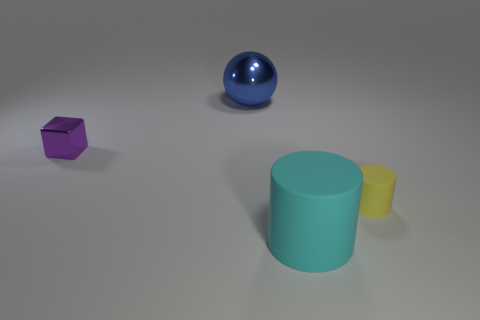There is a cyan matte object that is the same shape as the yellow matte thing; what size is it?
Provide a short and direct response. Large. What number of things are either small objects that are right of the shiny cube or objects right of the purple cube?
Provide a short and direct response. 3. Does the blue object have the same size as the cylinder that is in front of the yellow object?
Keep it short and to the point. Yes. Are the object in front of the small yellow matte cylinder and the small thing that is to the left of the tiny yellow cylinder made of the same material?
Ensure brevity in your answer.  No. Is the number of metal objects left of the big cylinder the same as the number of small matte cylinders behind the metal cube?
Offer a terse response. No. How many metal blocks are the same color as the big cylinder?
Keep it short and to the point. 0. What number of shiny things are either big spheres or red things?
Make the answer very short. 1. Do the small object on the right side of the big cylinder and the big thing that is behind the small purple shiny block have the same shape?
Offer a very short reply. No. There is a blue metallic sphere; how many spheres are behind it?
Provide a short and direct response. 0. Are there any big cyan things made of the same material as the sphere?
Offer a very short reply. No. 